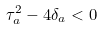<formula> <loc_0><loc_0><loc_500><loc_500>\tau _ { a } ^ { 2 } - 4 \delta _ { a } < 0</formula> 